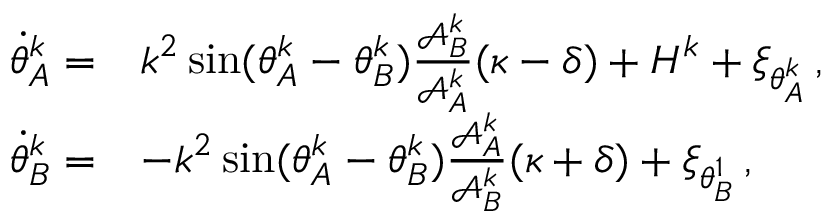<formula> <loc_0><loc_0><loc_500><loc_500>\begin{array} { r l } { \dot { \theta } _ { A } ^ { k } = } & { k ^ { 2 } \sin ( \theta _ { A } ^ { k } - \theta _ { B } ^ { k } ) \frac { \mathcal { A } _ { B } ^ { k } } { \mathcal { A } _ { A } ^ { k } } ( \kappa - \delta ) + H ^ { k } + \xi _ { \theta _ { A } ^ { k } } \, , } \\ { \dot { \theta } _ { B } ^ { k } = } & { - k ^ { 2 } \sin ( \theta _ { A } ^ { k } - \theta _ { B } ^ { k } ) \frac { \mathcal { A } _ { A } ^ { k } } { \mathcal { A } _ { B } ^ { k } } ( \kappa + \delta ) + \xi _ { \theta _ { B } ^ { 1 } } \, , } \end{array}</formula> 